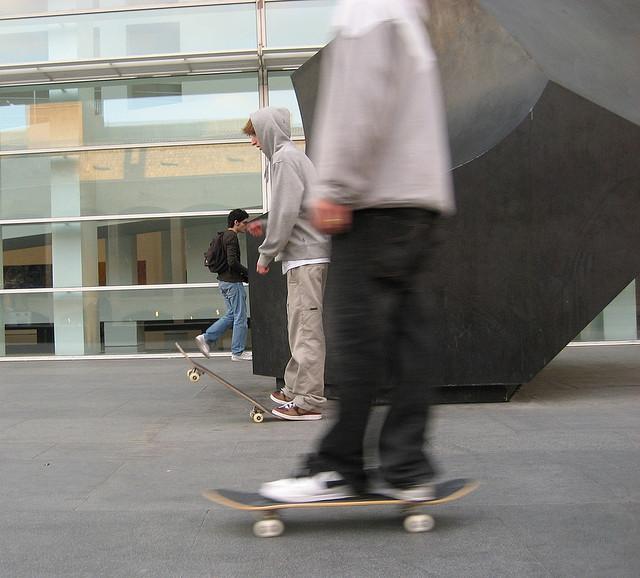Could this be a college campus?
Concise answer only. Yes. How many skateboard wheels can be seen?
Quick response, please. 6. How many backpacks are in this photo?
Answer briefly. 1. 